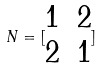<formula> <loc_0><loc_0><loc_500><loc_500>N = [ \begin{matrix} 1 & 2 \\ 2 & 1 \end{matrix} ]</formula> 